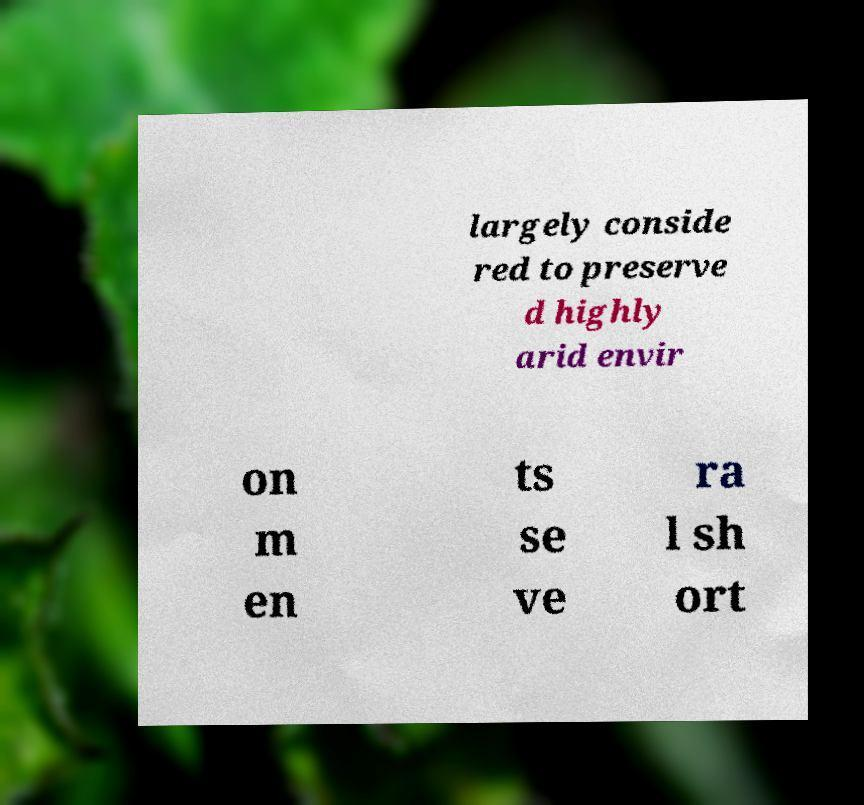Can you read and provide the text displayed in the image?This photo seems to have some interesting text. Can you extract and type it out for me? largely conside red to preserve d highly arid envir on m en ts se ve ra l sh ort 